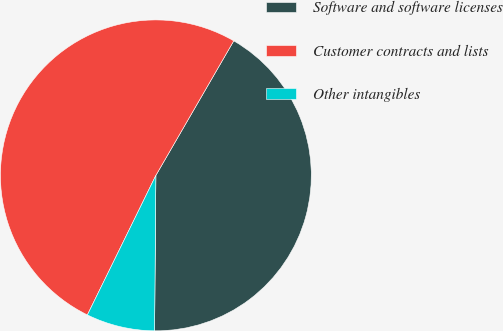<chart> <loc_0><loc_0><loc_500><loc_500><pie_chart><fcel>Software and software licenses<fcel>Customer contracts and lists<fcel>Other intangibles<nl><fcel>41.78%<fcel>51.09%<fcel>7.13%<nl></chart> 